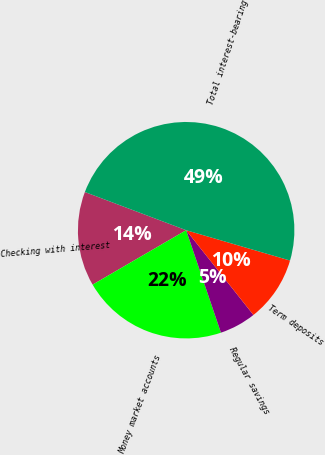Convert chart. <chart><loc_0><loc_0><loc_500><loc_500><pie_chart><fcel>Checking with interest<fcel>Money market accounts<fcel>Regular savings<fcel>Term deposits<fcel>Total interest-bearing<nl><fcel>14.13%<fcel>21.82%<fcel>5.47%<fcel>9.8%<fcel>48.79%<nl></chart> 